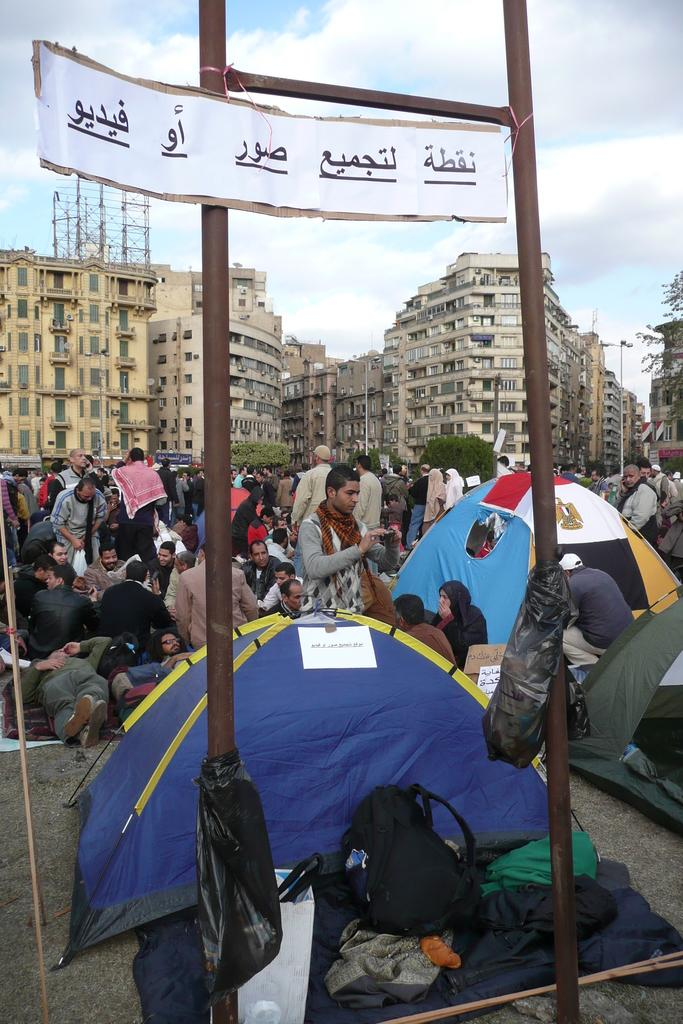How many people are in the image? There is a group of people in the image, but the exact number cannot be determined from the provided facts. What type of temporary shelters can be seen in the image? There are tents in the image. What items might be used for carrying belongings? Bags are present in the image. What is lying on the ground in the image? Clothes are present on the ground in the image. What structures are used to support the tents or other objects? There are poles in the image. What type of permanent structures can be seen in the image? There are buildings in the image. What type of vegetation is visible in the image? Trees are visible in the image. What other objects can be seen in the image? There are various objects in the image, but their specific nature cannot be determined from the provided facts. What is visible in the background of the image? The sky is visible in the background of the image. What color is the paint being used to decorate the tents in the image? There is no mention of paint or any decoration being applied to the tents in the image. What wish is being granted to the people in the image? There is no indication of a wish being granted to the people in the image. 